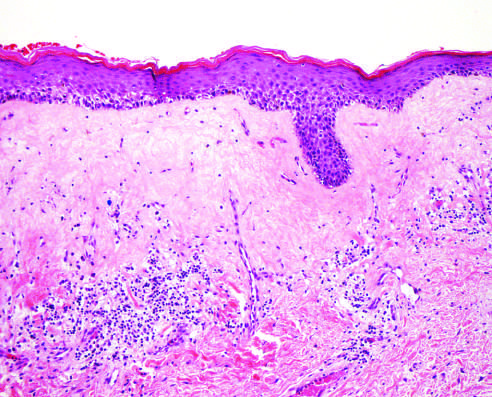s there marked thinning of the epidermis, fibrosis of the superficial dermis, and chronic inflammatory cells in the deeper dermis?
Answer the question using a single word or phrase. Yes 